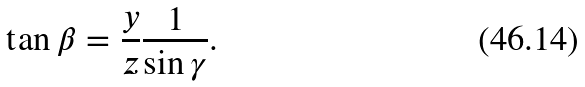Convert formula to latex. <formula><loc_0><loc_0><loc_500><loc_500>\tan { \beta } = \frac { y } { z } \frac { 1 } { \sin { \gamma } } .</formula> 